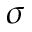Convert formula to latex. <formula><loc_0><loc_0><loc_500><loc_500>\sigma</formula> 